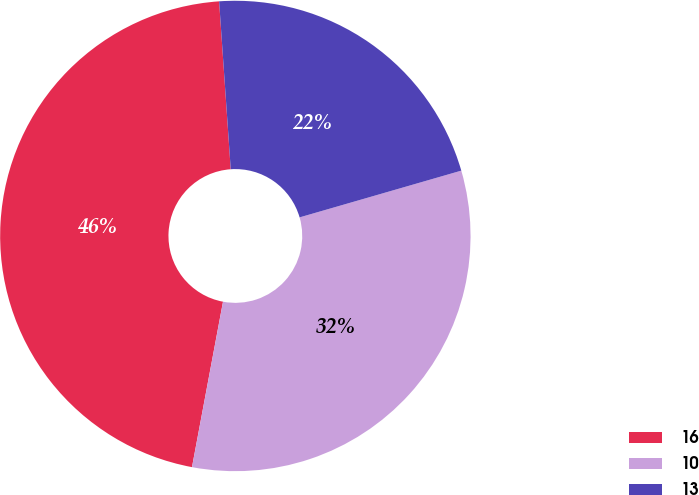<chart> <loc_0><loc_0><loc_500><loc_500><pie_chart><fcel>16<fcel>10<fcel>13<nl><fcel>45.95%<fcel>32.43%<fcel>21.62%<nl></chart> 